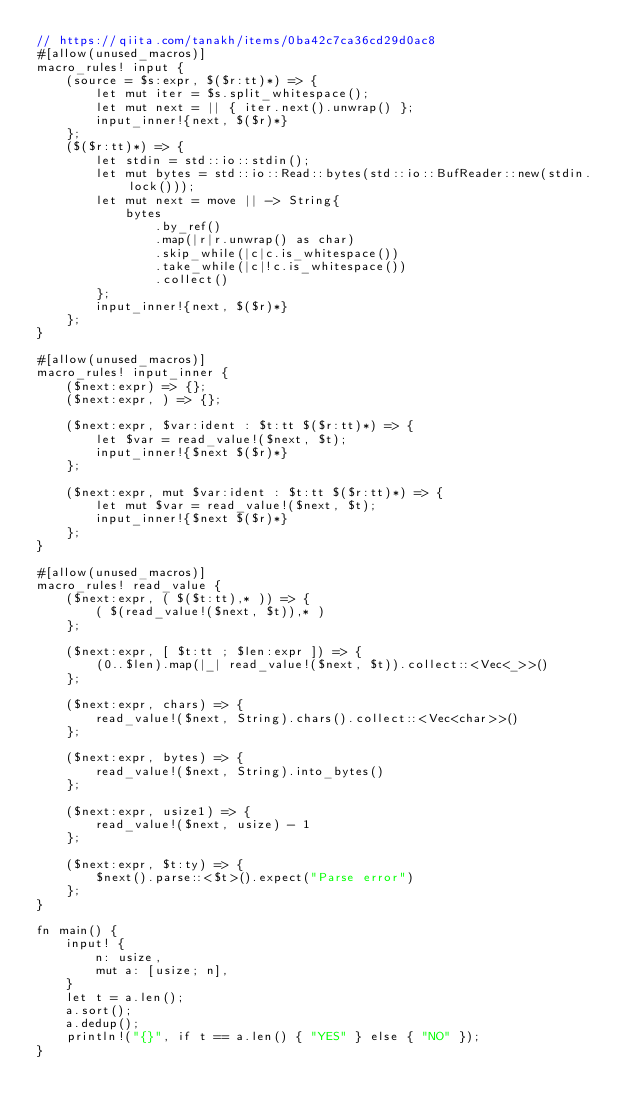<code> <loc_0><loc_0><loc_500><loc_500><_Rust_>// https://qiita.com/tanakh/items/0ba42c7ca36cd29d0ac8
#[allow(unused_macros)]
macro_rules! input {
    (source = $s:expr, $($r:tt)*) => {
        let mut iter = $s.split_whitespace();
        let mut next = || { iter.next().unwrap() };
        input_inner!{next, $($r)*}
    };
    ($($r:tt)*) => {
        let stdin = std::io::stdin();
        let mut bytes = std::io::Read::bytes(std::io::BufReader::new(stdin.lock()));
        let mut next = move || -> String{
            bytes
                .by_ref()
                .map(|r|r.unwrap() as char)
                .skip_while(|c|c.is_whitespace())
                .take_while(|c|!c.is_whitespace())
                .collect()
        };
        input_inner!{next, $($r)*}
    };
}

#[allow(unused_macros)]
macro_rules! input_inner {
    ($next:expr) => {};
    ($next:expr, ) => {};

    ($next:expr, $var:ident : $t:tt $($r:tt)*) => {
        let $var = read_value!($next, $t);
        input_inner!{$next $($r)*}
    };

    ($next:expr, mut $var:ident : $t:tt $($r:tt)*) => {
        let mut $var = read_value!($next, $t);
        input_inner!{$next $($r)*}
    };
}

#[allow(unused_macros)]
macro_rules! read_value {
    ($next:expr, ( $($t:tt),* )) => {
        ( $(read_value!($next, $t)),* )
    };

    ($next:expr, [ $t:tt ; $len:expr ]) => {
        (0..$len).map(|_| read_value!($next, $t)).collect::<Vec<_>>()
    };

    ($next:expr, chars) => {
        read_value!($next, String).chars().collect::<Vec<char>>()
    };

    ($next:expr, bytes) => {
        read_value!($next, String).into_bytes()
    };

    ($next:expr, usize1) => {
        read_value!($next, usize) - 1
    };

    ($next:expr, $t:ty) => {
        $next().parse::<$t>().expect("Parse error")
    };
}

fn main() {
    input! {
        n: usize,
        mut a: [usize; n],
    }
    let t = a.len();
    a.sort();
    a.dedup();
    println!("{}", if t == a.len() { "YES" } else { "NO" });
}
</code> 